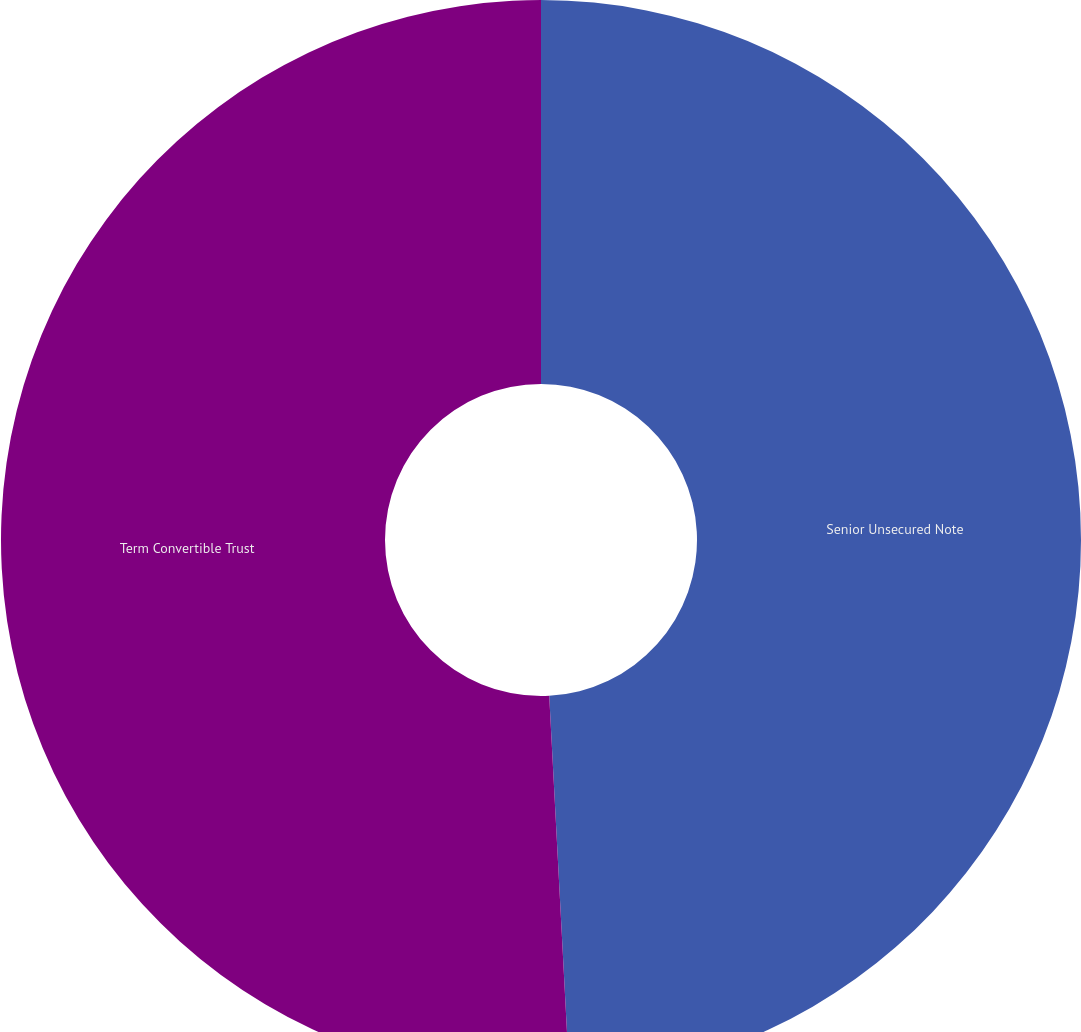Convert chart to OTSL. <chart><loc_0><loc_0><loc_500><loc_500><pie_chart><fcel>Senior Unsecured Note<fcel>Term Convertible Trust<nl><fcel>49.16%<fcel>50.84%<nl></chart> 